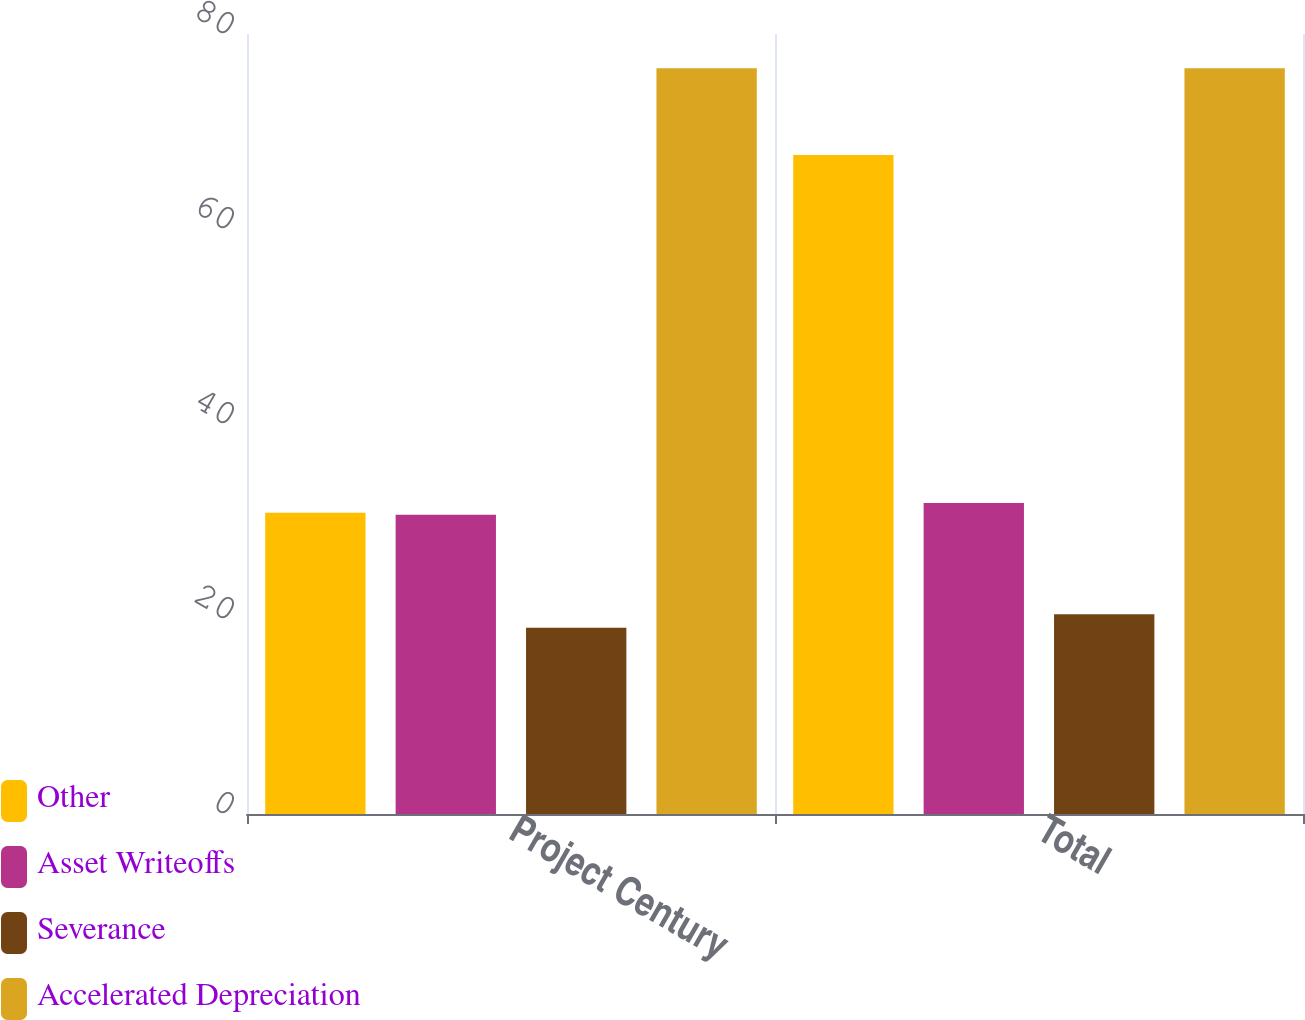Convert chart to OTSL. <chart><loc_0><loc_0><loc_500><loc_500><stacked_bar_chart><ecel><fcel>Project Century<fcel>Total<nl><fcel>Other<fcel>30.9<fcel>67.6<nl><fcel>Asset Writeoffs<fcel>30.7<fcel>31.9<nl><fcel>Severance<fcel>19.1<fcel>20.5<nl><fcel>Accelerated Depreciation<fcel>76.5<fcel>76.5<nl></chart> 